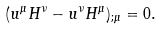Convert formula to latex. <formula><loc_0><loc_0><loc_500><loc_500>( u ^ { \mu } H ^ { \nu } - u ^ { \nu } H ^ { \mu } ) _ { ; \mu } = 0 .</formula> 